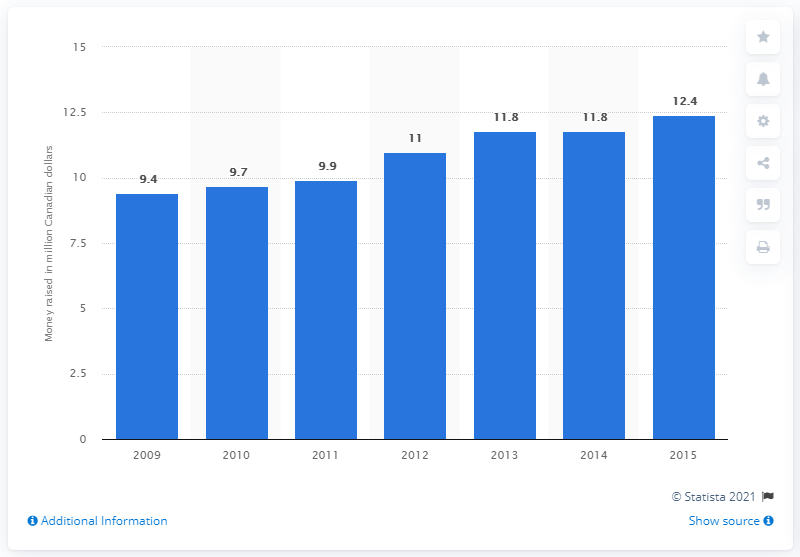Highlight a few significant elements in this photo. Tim Hortons' Camp Day fundraising on June 4, 2014, was successful, raising 11.8 million dollars. 